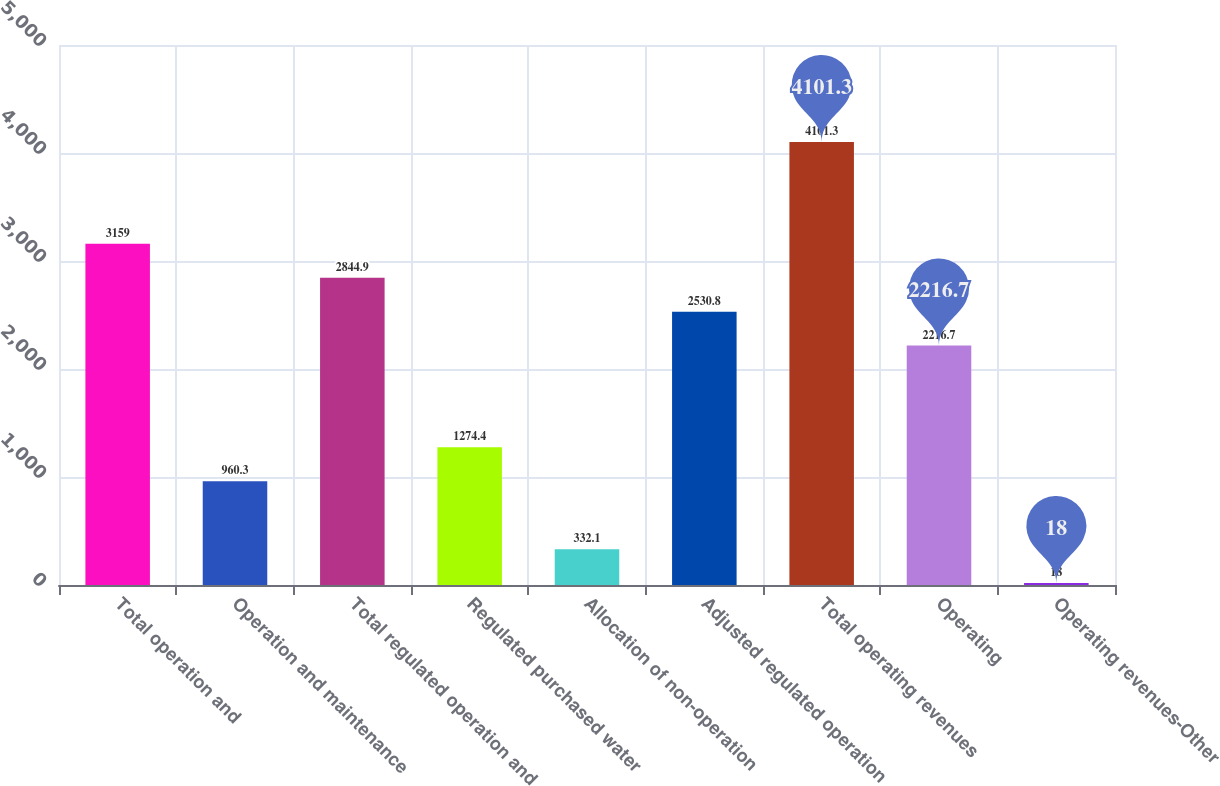Convert chart to OTSL. <chart><loc_0><loc_0><loc_500><loc_500><bar_chart><fcel>Total operation and<fcel>Operation and maintenance<fcel>Total regulated operation and<fcel>Regulated purchased water<fcel>Allocation of non-operation<fcel>Adjusted regulated operation<fcel>Total operating revenues<fcel>Operating<fcel>Operating revenues-Other<nl><fcel>3159<fcel>960.3<fcel>2844.9<fcel>1274.4<fcel>332.1<fcel>2530.8<fcel>4101.3<fcel>2216.7<fcel>18<nl></chart> 